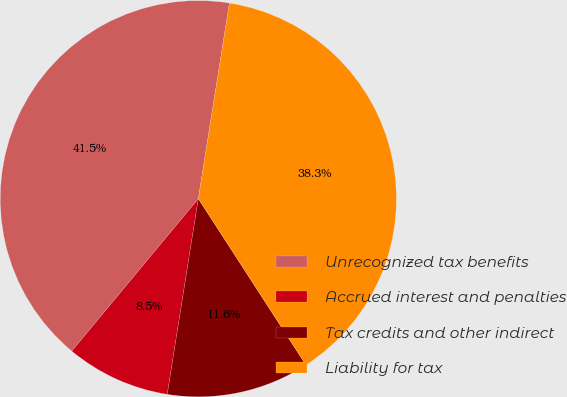Convert chart. <chart><loc_0><loc_0><loc_500><loc_500><pie_chart><fcel>Unrecognized tax benefits<fcel>Accrued interest and penalties<fcel>Tax credits and other indirect<fcel>Liability for tax<nl><fcel>41.48%<fcel>8.52%<fcel>11.65%<fcel>38.35%<nl></chart> 